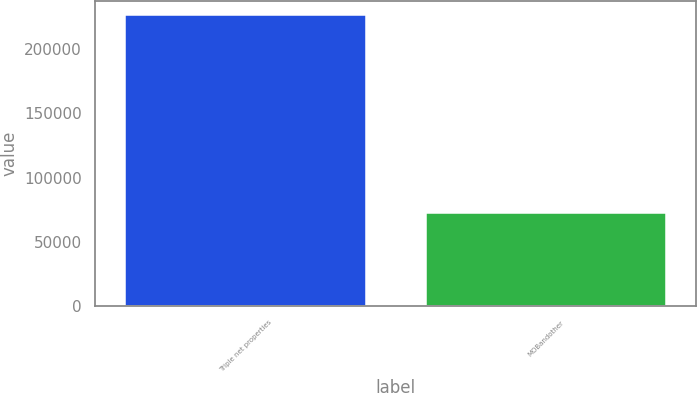Convert chart. <chart><loc_0><loc_0><loc_500><loc_500><bar_chart><fcel>Triple net properties<fcel>MOBandother<nl><fcel>226228<fcel>72538<nl></chart> 